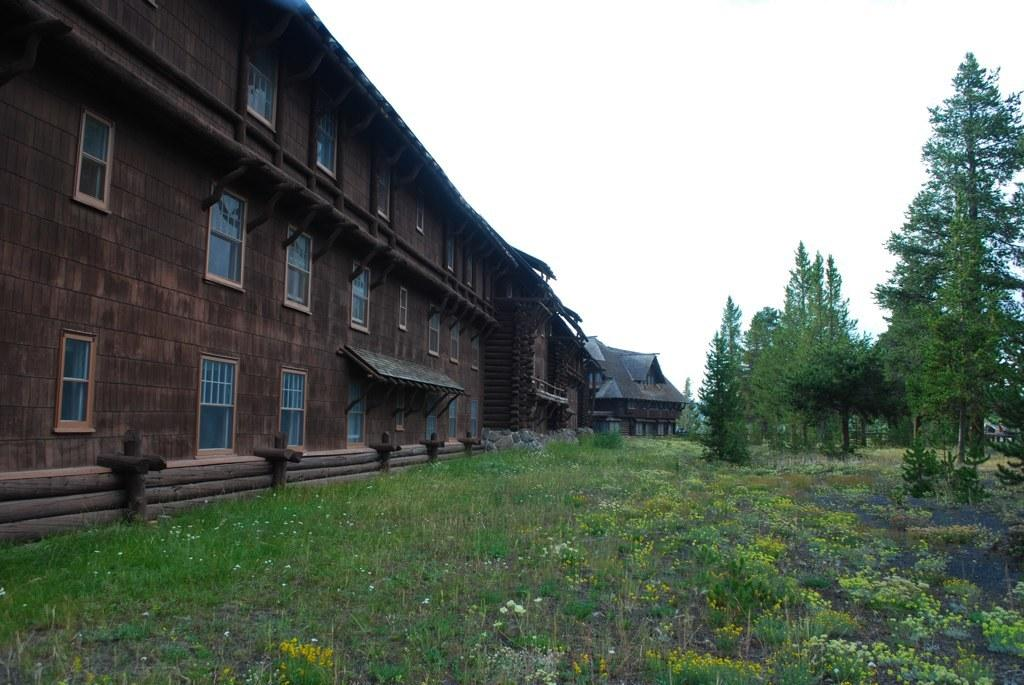What type of structure is present in the image? There is a building in the image. What objects in the image reflect light or images? There are mirrors in the image. What type of natural material is present in the image? There are logs in the image. What part of the natural environment is visible in the image? The sky is visible in the image. What type of vegetation is present in the image? There are trees, plants, and grass in the image. Can you see an airplane flying in the image? No, there is no airplane visible in the image. Is there a bear interacting with the logs in the image? No, there is no bear present in the image. 